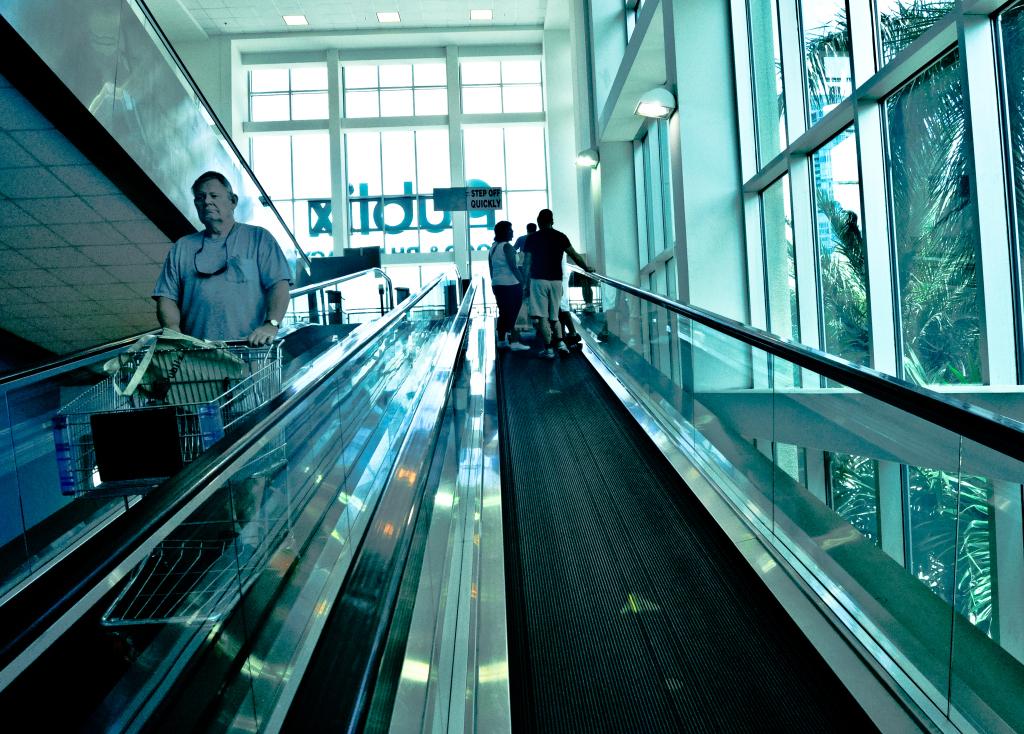What store is this?
Your answer should be very brief. Publix. 